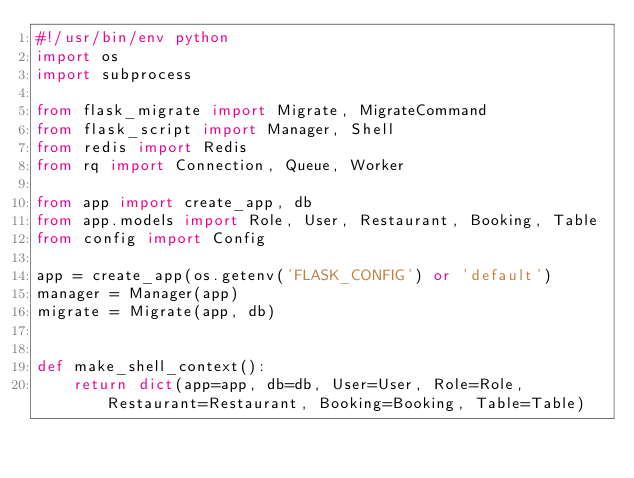Convert code to text. <code><loc_0><loc_0><loc_500><loc_500><_Python_>#!/usr/bin/env python
import os
import subprocess

from flask_migrate import Migrate, MigrateCommand
from flask_script import Manager, Shell
from redis import Redis
from rq import Connection, Queue, Worker

from app import create_app, db
from app.models import Role, User, Restaurant, Booking, Table
from config import Config

app = create_app(os.getenv('FLASK_CONFIG') or 'default')
manager = Manager(app)
migrate = Migrate(app, db)


def make_shell_context():
    return dict(app=app, db=db, User=User, Role=Role, Restaurant=Restaurant, Booking=Booking, Table=Table)

</code> 